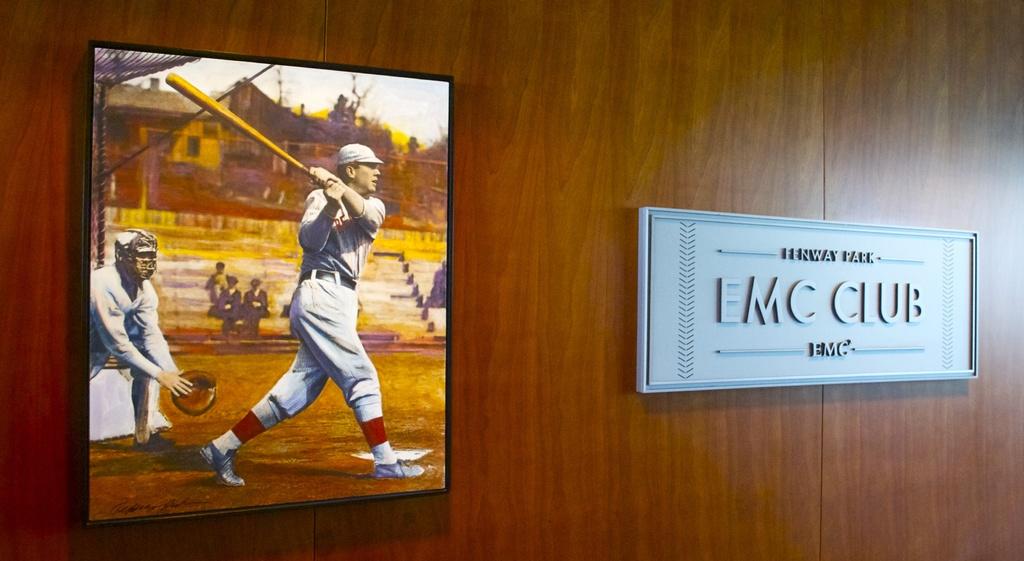What club is this?
Keep it short and to the point. Emc. What is the club name?
Offer a terse response. Emc club. 